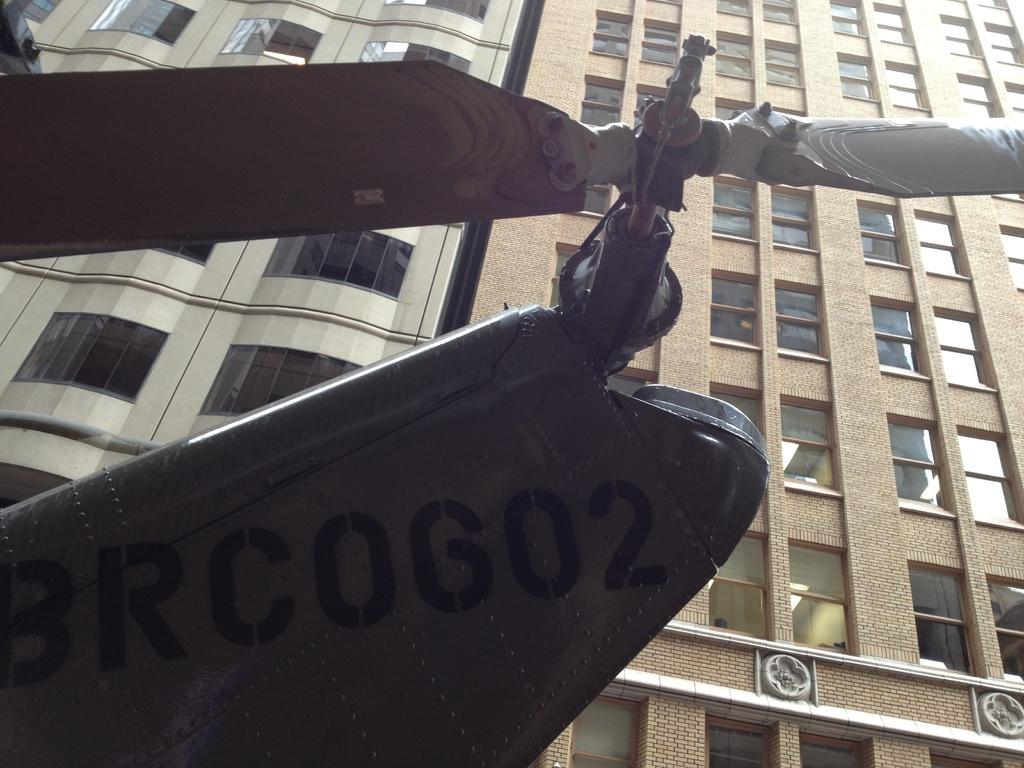What object with a fan is located on the left side of the image? There is an object with a fan on the left side of the image. What can be seen in the distance behind the object with a fan? There are buildings in the background of the image. What feature do the buildings in the image have? The buildings in the image have windows. How many fingers can be seen pointing at the object with a fan in the image? There are no fingers visible in the image, as it only features an object with a fan and buildings in the background. 